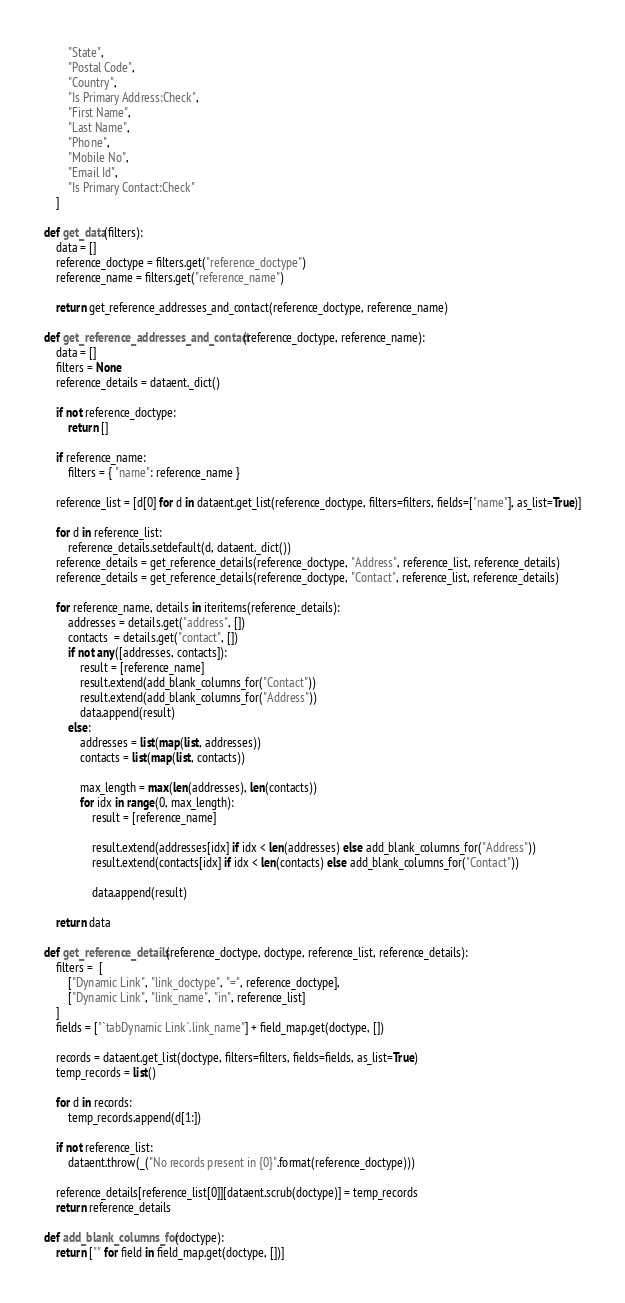<code> <loc_0><loc_0><loc_500><loc_500><_Python_>		"State",
		"Postal Code",
		"Country",
		"Is Primary Address:Check",
		"First Name",
		"Last Name",
		"Phone",
		"Mobile No",
		"Email Id",
		"Is Primary Contact:Check"
	]

def get_data(filters):
	data = []
	reference_doctype = filters.get("reference_doctype")
	reference_name = filters.get("reference_name")

	return get_reference_addresses_and_contact(reference_doctype, reference_name)

def get_reference_addresses_and_contact(reference_doctype, reference_name):
	data = []
	filters = None
	reference_details = dataent._dict()

	if not reference_doctype:
		return []

	if reference_name:
		filters = { "name": reference_name }

	reference_list = [d[0] for d in dataent.get_list(reference_doctype, filters=filters, fields=["name"], as_list=True)]

	for d in reference_list:
		reference_details.setdefault(d, dataent._dict())
	reference_details = get_reference_details(reference_doctype, "Address", reference_list, reference_details)
	reference_details = get_reference_details(reference_doctype, "Contact", reference_list, reference_details)

	for reference_name, details in iteritems(reference_details):
		addresses = details.get("address", [])
		contacts  = details.get("contact", [])
		if not any([addresses, contacts]):
			result = [reference_name]
			result.extend(add_blank_columns_for("Contact"))
			result.extend(add_blank_columns_for("Address"))
			data.append(result)
		else:
			addresses = list(map(list, addresses))
			contacts = list(map(list, contacts))

			max_length = max(len(addresses), len(contacts))
			for idx in range(0, max_length):
				result = [reference_name]

				result.extend(addresses[idx] if idx < len(addresses) else add_blank_columns_for("Address"))
				result.extend(contacts[idx] if idx < len(contacts) else add_blank_columns_for("Contact"))

				data.append(result)

	return data

def get_reference_details(reference_doctype, doctype, reference_list, reference_details):
	filters =  [
		["Dynamic Link", "link_doctype", "=", reference_doctype],
		["Dynamic Link", "link_name", "in", reference_list]
	]
	fields = ["`tabDynamic Link`.link_name"] + field_map.get(doctype, [])

	records = dataent.get_list(doctype, filters=filters, fields=fields, as_list=True)
	temp_records = list()

	for d in records:
		temp_records.append(d[1:])

	if not reference_list:
		dataent.throw(_("No records present in {0}".format(reference_doctype)))

	reference_details[reference_list[0]][dataent.scrub(doctype)] = temp_records
	return reference_details

def add_blank_columns_for(doctype):
	return ["" for field in field_map.get(doctype, [])]
</code> 